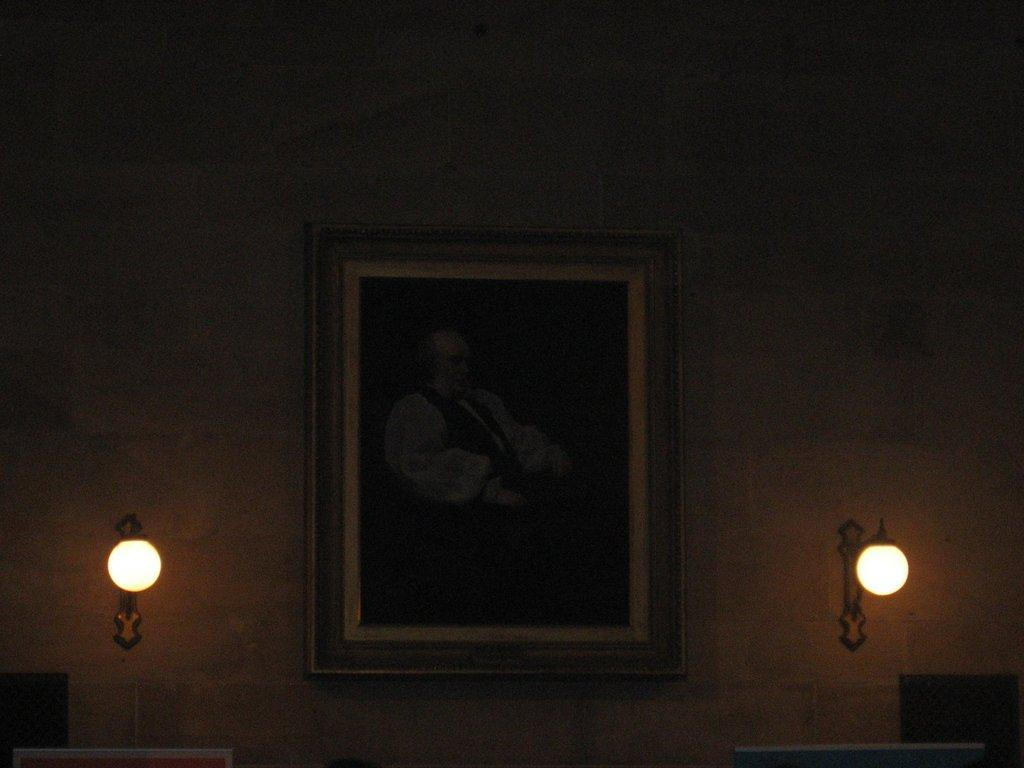What is the main subject of the image? The main subject of the image is a photo frame. Where is the photo frame located in the image? The photo frame is on the wall. What else can be seen near the photo frame in the image? There are lights beside the photo frame. How does the photo frame compare to the treatment of a patient in the image? There is no patient or treatment present in the image; it only features a photo frame on the wall with lights beside it. 